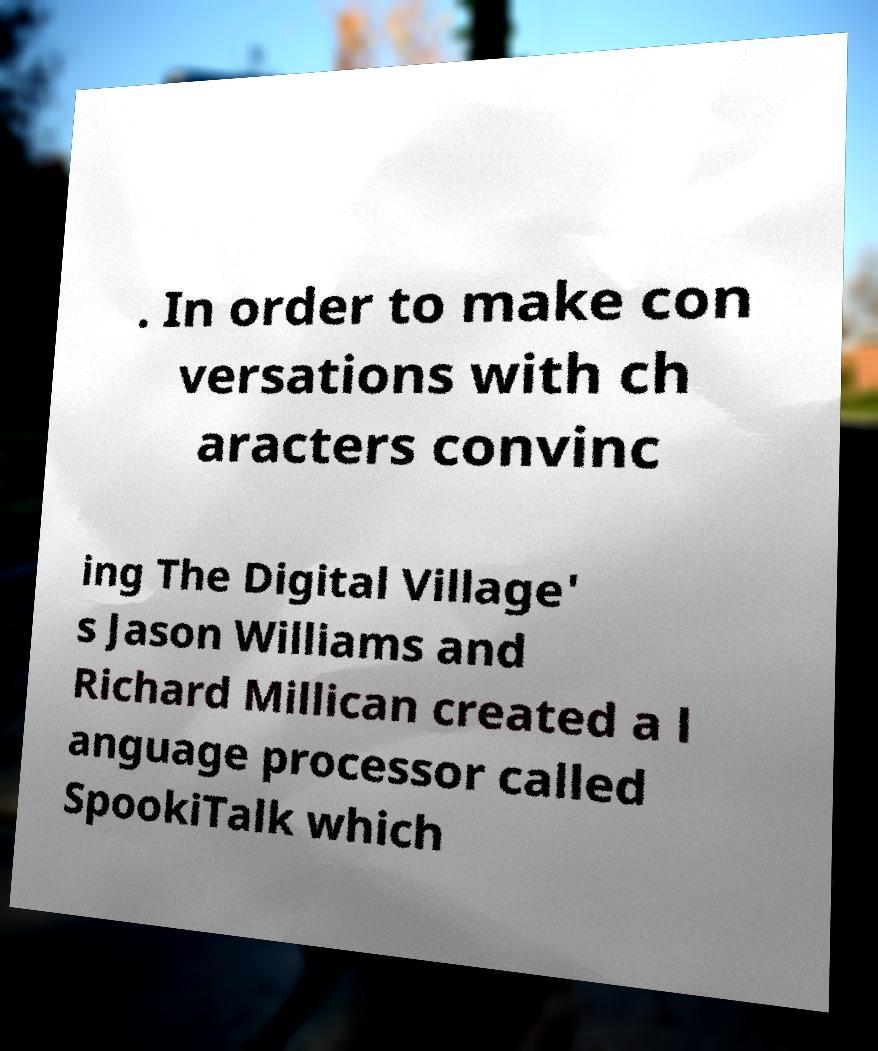Could you assist in decoding the text presented in this image and type it out clearly? . In order to make con versations with ch aracters convinc ing The Digital Village' s Jason Williams and Richard Millican created a l anguage processor called SpookiTalk which 